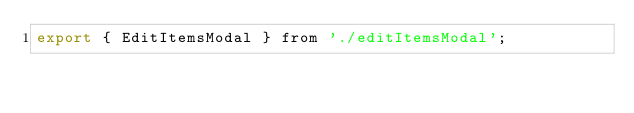Convert code to text. <code><loc_0><loc_0><loc_500><loc_500><_JavaScript_>export { EditItemsModal } from './editItemsModal';
</code> 